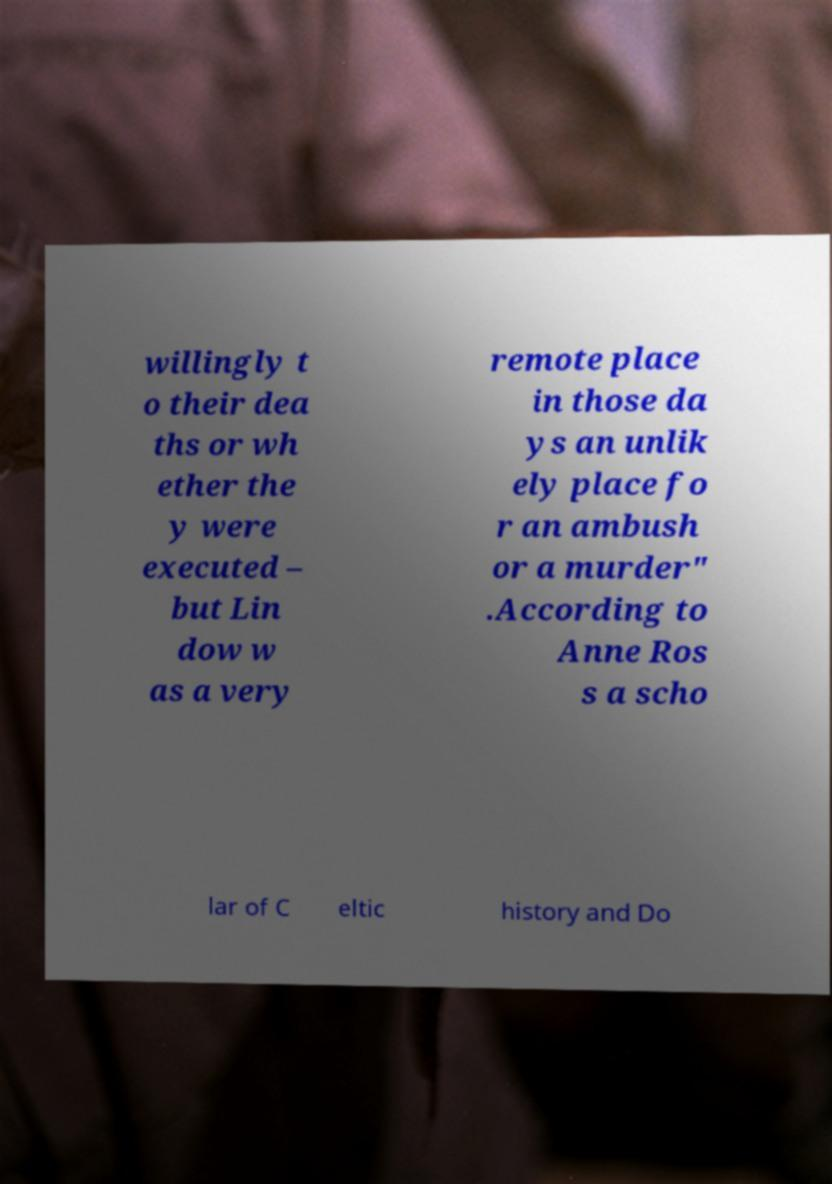I need the written content from this picture converted into text. Can you do that? willingly t o their dea ths or wh ether the y were executed – but Lin dow w as a very remote place in those da ys an unlik ely place fo r an ambush or a murder" .According to Anne Ros s a scho lar of C eltic history and Do 